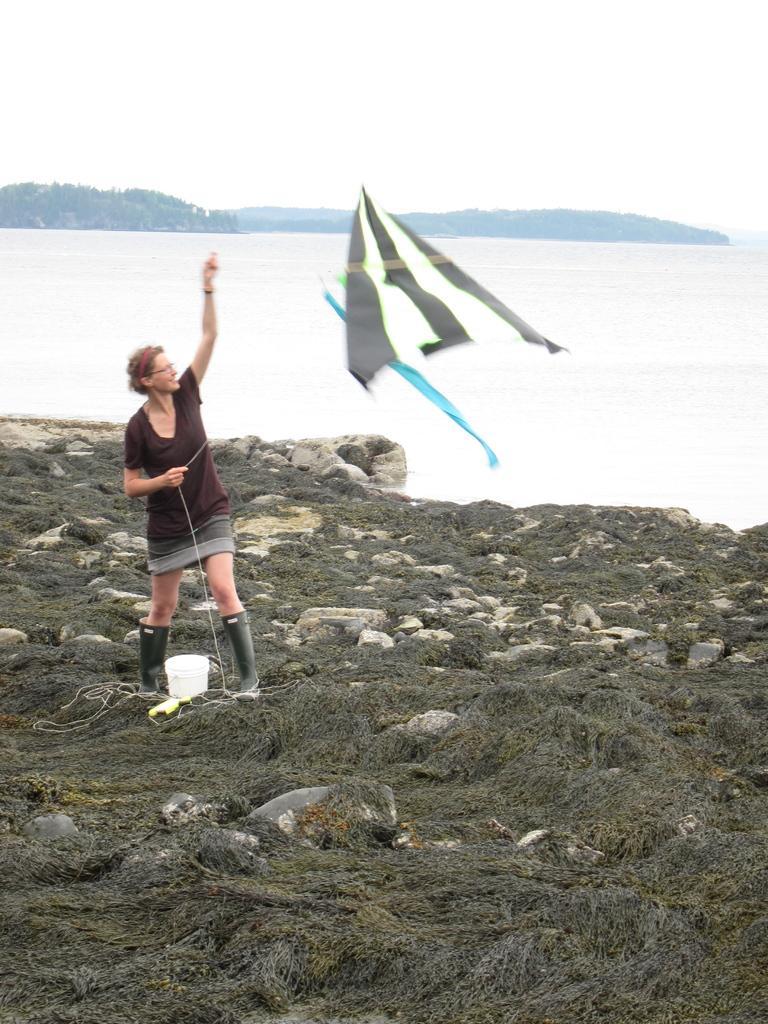Please provide a concise description of this image. In this picture I can see a woman standing and holding kite, behind we can see some rocks, water, back ground we can see some hills. 